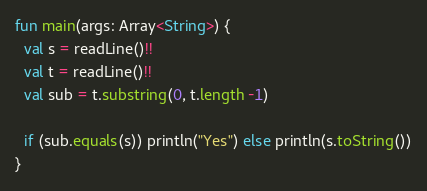<code> <loc_0><loc_0><loc_500><loc_500><_Kotlin_>fun main(args: Array<String>) {
  val s = readLine()!!
  val t = readLine()!! 
  val sub = t.substring(0, t.length -1)
  
  if (sub.equals(s)) println("Yes") else println(s.toString())
}</code> 